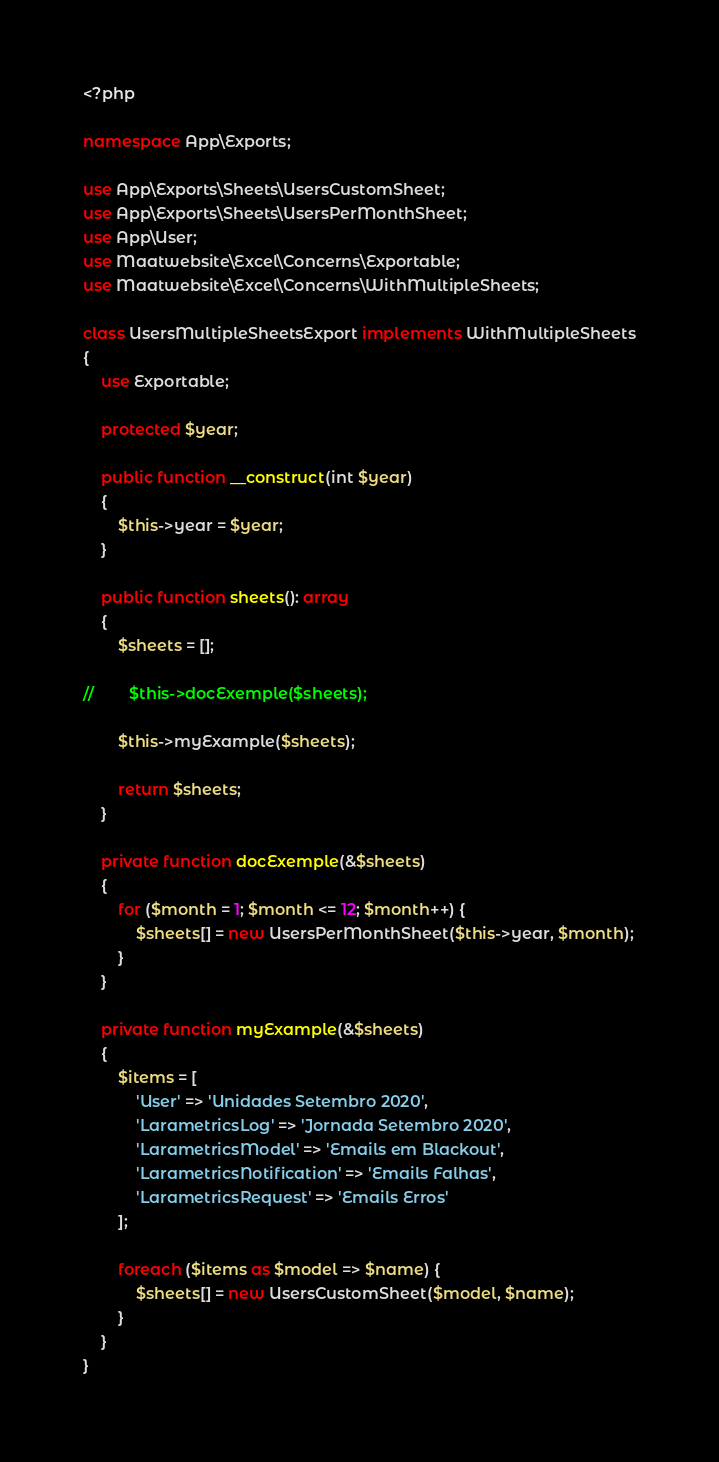Convert code to text. <code><loc_0><loc_0><loc_500><loc_500><_PHP_><?php

namespace App\Exports;

use App\Exports\Sheets\UsersCustomSheet;
use App\Exports\Sheets\UsersPerMonthSheet;
use App\User;
use Maatwebsite\Excel\Concerns\Exportable;
use Maatwebsite\Excel\Concerns\WithMultipleSheets;

class UsersMultipleSheetsExport implements WithMultipleSheets
{
    use Exportable;

    protected $year;

    public function __construct(int $year)
    {
        $this->year = $year;
    }

    public function sheets(): array
    {
        $sheets = [];

//        $this->docExemple($sheets);

        $this->myExample($sheets);

        return $sheets;
    }

    private function docExemple(&$sheets)
    {
        for ($month = 1; $month <= 12; $month++) {
            $sheets[] = new UsersPerMonthSheet($this->year, $month);
        }
    }

    private function myExample(&$sheets)
    {
        $items = [
            'User' => 'Unidades Setembro 2020',
            'LarametricsLog' => 'Jornada Setembro 2020',
            'LarametricsModel' => 'Emails em Blackout',
            'LarametricsNotification' => 'Emails Falhas',
            'LarametricsRequest' => 'Emails Erros'
        ];

        foreach ($items as $model => $name) {
            $sheets[] = new UsersCustomSheet($model, $name);
        }
    }
}
</code> 